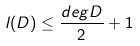Convert formula to latex. <formula><loc_0><loc_0><loc_500><loc_500>l ( D ) \leq \frac { d e g D } { 2 } + 1</formula> 